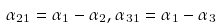<formula> <loc_0><loc_0><loc_500><loc_500>\alpha _ { 2 1 } = \alpha _ { 1 } - \alpha _ { 2 } , \alpha _ { 3 1 } = \alpha _ { 1 } - \alpha _ { 3 }</formula> 